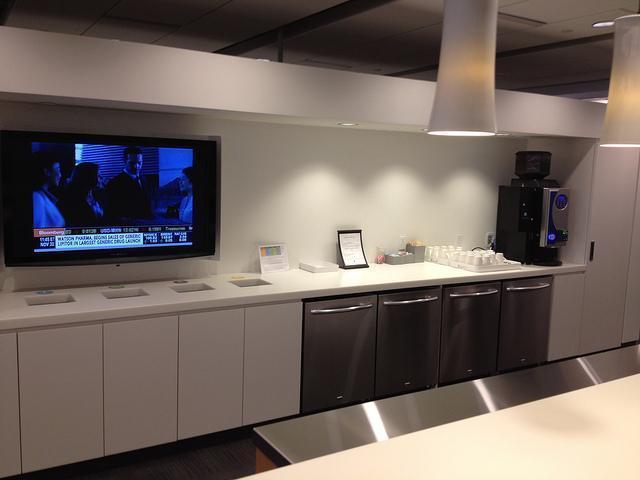What station is on the television?
Indicate the correct response by choosing from the four available options to answer the question.
Options: Cnn, fox, tbs, bloomberg. Bloomberg. 